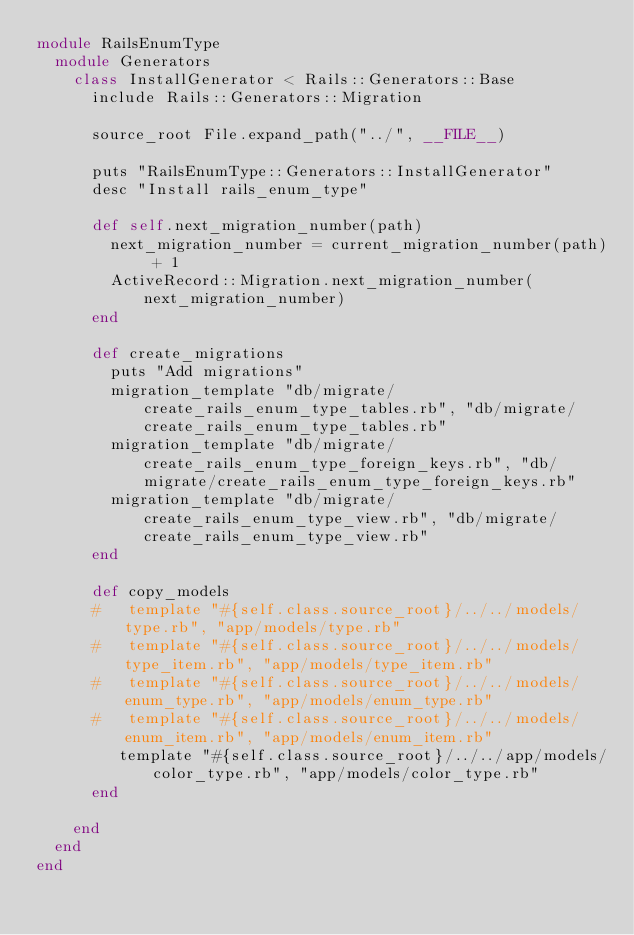Convert code to text. <code><loc_0><loc_0><loc_500><loc_500><_Ruby_>module RailsEnumType
  module Generators
    class InstallGenerator < Rails::Generators::Base
      include Rails::Generators::Migration

      source_root File.expand_path("../", __FILE__)

      puts "RailsEnumType::Generators::InstallGenerator"
      desc "Install rails_enum_type"

      def self.next_migration_number(path)
        next_migration_number = current_migration_number(path) + 1
        ActiveRecord::Migration.next_migration_number(next_migration_number)
      end

      def create_migrations
        puts "Add migrations"
        migration_template "db/migrate/create_rails_enum_type_tables.rb", "db/migrate/create_rails_enum_type_tables.rb"
        migration_template "db/migrate/create_rails_enum_type_foreign_keys.rb", "db/migrate/create_rails_enum_type_foreign_keys.rb"
        migration_template "db/migrate/create_rails_enum_type_view.rb", "db/migrate/create_rails_enum_type_view.rb"
      end

      def copy_models
      #   template "#{self.class.source_root}/../../models/type.rb", "app/models/type.rb"
      #   template "#{self.class.source_root}/../../models/type_item.rb", "app/models/type_item.rb"
      #   template "#{self.class.source_root}/../../models/enum_type.rb", "app/models/enum_type.rb"
      #   template "#{self.class.source_root}/../../models/enum_item.rb", "app/models/enum_item.rb"
         template "#{self.class.source_root}/../../app/models/color_type.rb", "app/models/color_type.rb"
      end

    end
  end
end</code> 